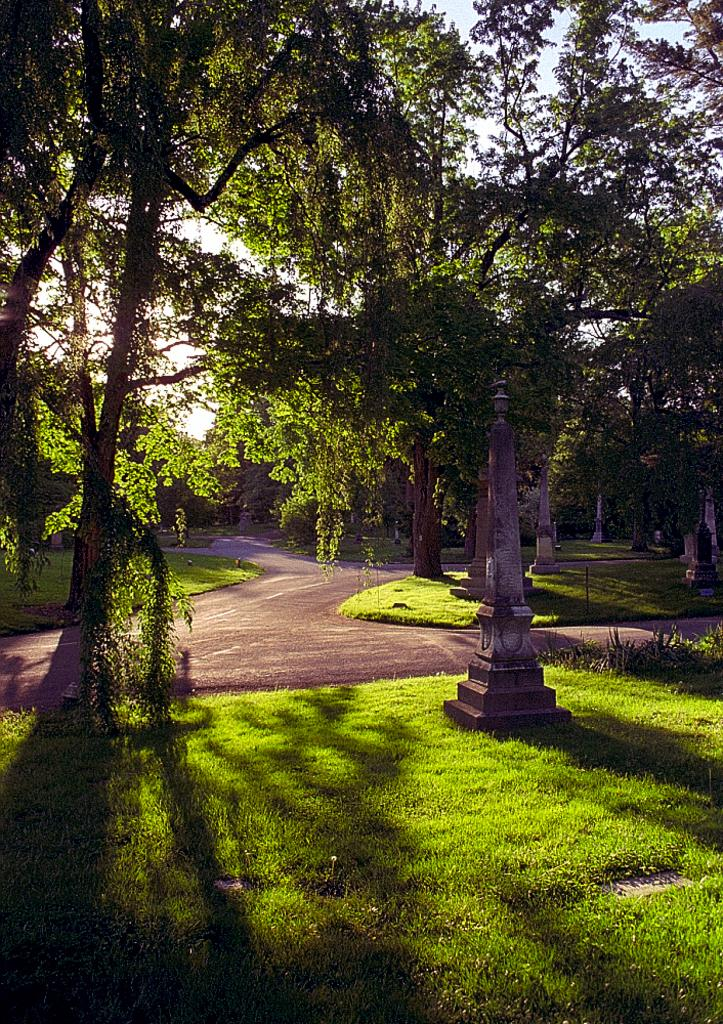What type of vegetation is present in the image? There is grass in the image. What type of man-made structure can be seen in the image? There is a road in the image. What other natural elements are present in the image? There are trees in the image. What is the condition of the sky in the image? The sky is clear in the image. How many geese are walking on the plate in the image? There are no geese or plates present in the image. What action are the geese performing on the plate in the image? Since there are no geese or plates in the image, this question cannot be answered. 